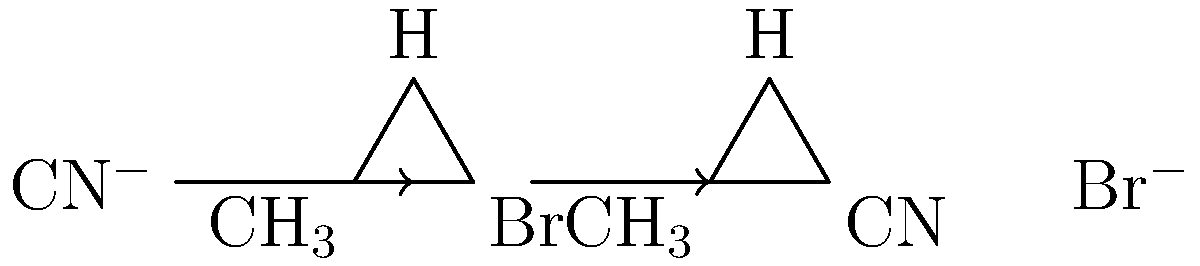Predict the product of the SN2 reaction shown in the diagram. What is the stereochemistry of the product? To predict the product of this SN2 reaction and determine its stereochemistry, let's follow these steps:

1. Identify the reactants:
   - The substrate is a methyl bromide (CH$_3$Br)
   - The nucleophile is a cyanide ion (CN$^-$)

2. Understand the SN2 mechanism:
   - SN2 reactions occur in one step
   - The nucleophile attacks from the back side, opposite to the leaving group

3. Analyze the reaction:
   - CN$^-$ approaches from the opposite side of the Br
   - As CN$^-$ bonds, Br$^-$ leaves simultaneously

4. Determine the product:
   - The carbon is now bonded to CN instead of Br
   - The product is methyl cyanide (CH$_3$CN)

5. Assess the stereochemistry:
   - SN2 reactions always result in inversion of configuration
   - However, in this case, the substrate is achiral (methyl group)
   - The product is also achiral

Therefore, the product is methyl cyanide (CH$_3$CN), and there is no change in stereochemistry due to the achiral nature of both the substrate and product.
Answer: CH$_3$CN (achiral) 